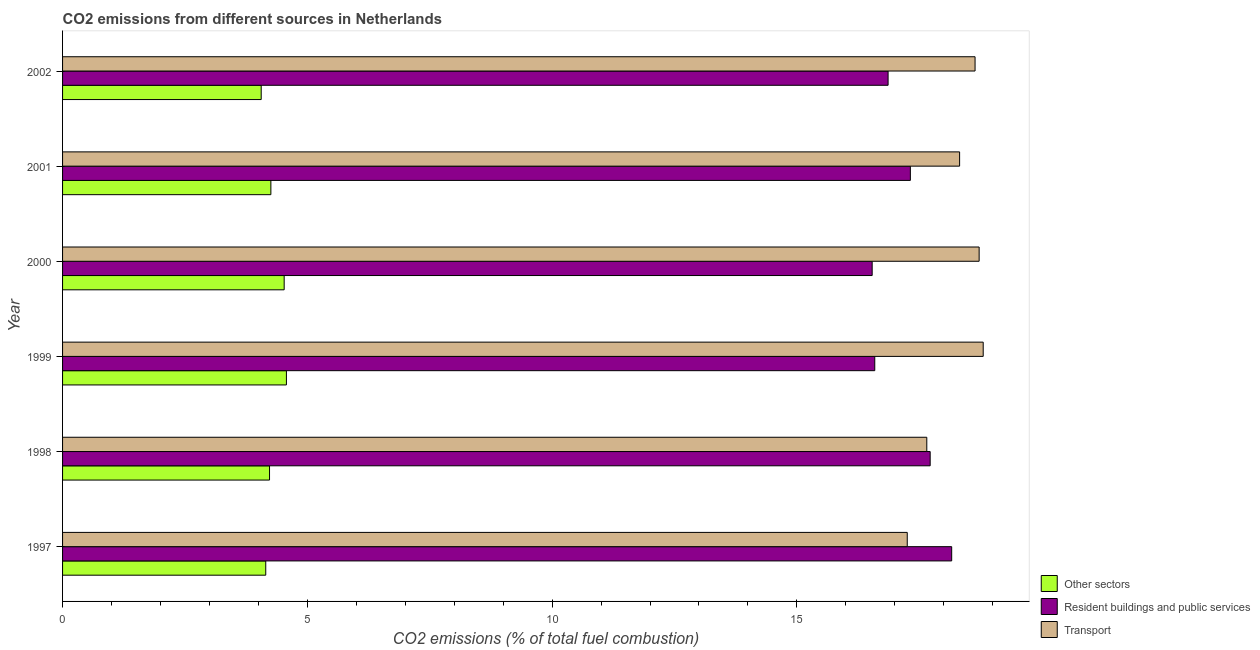Are the number of bars on each tick of the Y-axis equal?
Make the answer very short. Yes. How many bars are there on the 1st tick from the top?
Offer a terse response. 3. How many bars are there on the 4th tick from the bottom?
Your answer should be compact. 3. What is the percentage of co2 emissions from resident buildings and public services in 2000?
Your answer should be very brief. 16.54. Across all years, what is the maximum percentage of co2 emissions from other sectors?
Keep it short and to the point. 4.57. Across all years, what is the minimum percentage of co2 emissions from transport?
Your answer should be compact. 17.25. In which year was the percentage of co2 emissions from other sectors minimum?
Keep it short and to the point. 2002. What is the total percentage of co2 emissions from other sectors in the graph?
Ensure brevity in your answer.  25.79. What is the difference between the percentage of co2 emissions from transport in 1997 and that in 2002?
Your answer should be compact. -1.39. What is the difference between the percentage of co2 emissions from other sectors in 2001 and the percentage of co2 emissions from resident buildings and public services in 2002?
Give a very brief answer. -12.61. What is the average percentage of co2 emissions from transport per year?
Your answer should be compact. 18.23. In the year 1998, what is the difference between the percentage of co2 emissions from transport and percentage of co2 emissions from resident buildings and public services?
Your answer should be compact. -0.07. In how many years, is the percentage of co2 emissions from resident buildings and public services greater than 4 %?
Provide a succinct answer. 6. Is the percentage of co2 emissions from other sectors in 1998 less than that in 2001?
Make the answer very short. Yes. What is the difference between the highest and the second highest percentage of co2 emissions from other sectors?
Give a very brief answer. 0.05. What is the difference between the highest and the lowest percentage of co2 emissions from resident buildings and public services?
Your answer should be very brief. 1.62. In how many years, is the percentage of co2 emissions from transport greater than the average percentage of co2 emissions from transport taken over all years?
Provide a succinct answer. 4. Is the sum of the percentage of co2 emissions from resident buildings and public services in 1997 and 1998 greater than the maximum percentage of co2 emissions from transport across all years?
Keep it short and to the point. Yes. What does the 3rd bar from the top in 2001 represents?
Give a very brief answer. Other sectors. What does the 3rd bar from the bottom in 2000 represents?
Offer a very short reply. Transport. Is it the case that in every year, the sum of the percentage of co2 emissions from other sectors and percentage of co2 emissions from resident buildings and public services is greater than the percentage of co2 emissions from transport?
Give a very brief answer. Yes. Are all the bars in the graph horizontal?
Make the answer very short. Yes. Are the values on the major ticks of X-axis written in scientific E-notation?
Provide a succinct answer. No. Does the graph contain any zero values?
Ensure brevity in your answer.  No. Where does the legend appear in the graph?
Provide a short and direct response. Bottom right. How many legend labels are there?
Offer a very short reply. 3. What is the title of the graph?
Make the answer very short. CO2 emissions from different sources in Netherlands. What is the label or title of the X-axis?
Keep it short and to the point. CO2 emissions (% of total fuel combustion). What is the CO2 emissions (% of total fuel combustion) of Other sectors in 1997?
Offer a terse response. 4.15. What is the CO2 emissions (% of total fuel combustion) of Resident buildings and public services in 1997?
Keep it short and to the point. 18.16. What is the CO2 emissions (% of total fuel combustion) of Transport in 1997?
Provide a succinct answer. 17.25. What is the CO2 emissions (% of total fuel combustion) of Other sectors in 1998?
Offer a terse response. 4.23. What is the CO2 emissions (% of total fuel combustion) in Resident buildings and public services in 1998?
Your response must be concise. 17.72. What is the CO2 emissions (% of total fuel combustion) of Transport in 1998?
Keep it short and to the point. 17.65. What is the CO2 emissions (% of total fuel combustion) in Other sectors in 1999?
Provide a succinct answer. 4.57. What is the CO2 emissions (% of total fuel combustion) in Resident buildings and public services in 1999?
Provide a short and direct response. 16.59. What is the CO2 emissions (% of total fuel combustion) in Transport in 1999?
Make the answer very short. 18.81. What is the CO2 emissions (% of total fuel combustion) of Other sectors in 2000?
Make the answer very short. 4.53. What is the CO2 emissions (% of total fuel combustion) of Resident buildings and public services in 2000?
Your response must be concise. 16.54. What is the CO2 emissions (% of total fuel combustion) of Transport in 2000?
Provide a short and direct response. 18.72. What is the CO2 emissions (% of total fuel combustion) in Other sectors in 2001?
Your response must be concise. 4.25. What is the CO2 emissions (% of total fuel combustion) of Resident buildings and public services in 2001?
Your answer should be very brief. 17.32. What is the CO2 emissions (% of total fuel combustion) in Transport in 2001?
Ensure brevity in your answer.  18.32. What is the CO2 emissions (% of total fuel combustion) in Other sectors in 2002?
Offer a very short reply. 4.06. What is the CO2 emissions (% of total fuel combustion) in Resident buildings and public services in 2002?
Your response must be concise. 16.86. What is the CO2 emissions (% of total fuel combustion) of Transport in 2002?
Offer a terse response. 18.64. Across all years, what is the maximum CO2 emissions (% of total fuel combustion) in Other sectors?
Provide a succinct answer. 4.57. Across all years, what is the maximum CO2 emissions (% of total fuel combustion) of Resident buildings and public services?
Give a very brief answer. 18.16. Across all years, what is the maximum CO2 emissions (% of total fuel combustion) of Transport?
Keep it short and to the point. 18.81. Across all years, what is the minimum CO2 emissions (% of total fuel combustion) of Other sectors?
Your answer should be very brief. 4.06. Across all years, what is the minimum CO2 emissions (% of total fuel combustion) of Resident buildings and public services?
Give a very brief answer. 16.54. Across all years, what is the minimum CO2 emissions (% of total fuel combustion) in Transport?
Give a very brief answer. 17.25. What is the total CO2 emissions (% of total fuel combustion) in Other sectors in the graph?
Make the answer very short. 25.79. What is the total CO2 emissions (% of total fuel combustion) of Resident buildings and public services in the graph?
Your answer should be very brief. 103.19. What is the total CO2 emissions (% of total fuel combustion) of Transport in the graph?
Give a very brief answer. 109.4. What is the difference between the CO2 emissions (% of total fuel combustion) in Other sectors in 1997 and that in 1998?
Give a very brief answer. -0.08. What is the difference between the CO2 emissions (% of total fuel combustion) of Resident buildings and public services in 1997 and that in 1998?
Keep it short and to the point. 0.44. What is the difference between the CO2 emissions (% of total fuel combustion) in Transport in 1997 and that in 1998?
Offer a very short reply. -0.4. What is the difference between the CO2 emissions (% of total fuel combustion) of Other sectors in 1997 and that in 1999?
Ensure brevity in your answer.  -0.42. What is the difference between the CO2 emissions (% of total fuel combustion) of Resident buildings and public services in 1997 and that in 1999?
Your response must be concise. 1.57. What is the difference between the CO2 emissions (% of total fuel combustion) of Transport in 1997 and that in 1999?
Keep it short and to the point. -1.55. What is the difference between the CO2 emissions (% of total fuel combustion) of Other sectors in 1997 and that in 2000?
Give a very brief answer. -0.38. What is the difference between the CO2 emissions (% of total fuel combustion) in Resident buildings and public services in 1997 and that in 2000?
Keep it short and to the point. 1.62. What is the difference between the CO2 emissions (% of total fuel combustion) of Transport in 1997 and that in 2000?
Provide a succinct answer. -1.47. What is the difference between the CO2 emissions (% of total fuel combustion) in Other sectors in 1997 and that in 2001?
Give a very brief answer. -0.1. What is the difference between the CO2 emissions (% of total fuel combustion) in Resident buildings and public services in 1997 and that in 2001?
Your response must be concise. 0.84. What is the difference between the CO2 emissions (% of total fuel combustion) of Transport in 1997 and that in 2001?
Give a very brief answer. -1.07. What is the difference between the CO2 emissions (% of total fuel combustion) in Other sectors in 1997 and that in 2002?
Ensure brevity in your answer.  0.09. What is the difference between the CO2 emissions (% of total fuel combustion) in Resident buildings and public services in 1997 and that in 2002?
Provide a short and direct response. 1.3. What is the difference between the CO2 emissions (% of total fuel combustion) in Transport in 1997 and that in 2002?
Offer a very short reply. -1.39. What is the difference between the CO2 emissions (% of total fuel combustion) of Other sectors in 1998 and that in 1999?
Keep it short and to the point. -0.34. What is the difference between the CO2 emissions (% of total fuel combustion) in Resident buildings and public services in 1998 and that in 1999?
Ensure brevity in your answer.  1.13. What is the difference between the CO2 emissions (% of total fuel combustion) in Transport in 1998 and that in 1999?
Provide a succinct answer. -1.15. What is the difference between the CO2 emissions (% of total fuel combustion) of Other sectors in 1998 and that in 2000?
Provide a succinct answer. -0.3. What is the difference between the CO2 emissions (% of total fuel combustion) of Resident buildings and public services in 1998 and that in 2000?
Give a very brief answer. 1.18. What is the difference between the CO2 emissions (% of total fuel combustion) of Transport in 1998 and that in 2000?
Give a very brief answer. -1.07. What is the difference between the CO2 emissions (% of total fuel combustion) of Other sectors in 1998 and that in 2001?
Provide a short and direct response. -0.03. What is the difference between the CO2 emissions (% of total fuel combustion) of Resident buildings and public services in 1998 and that in 2001?
Provide a short and direct response. 0.4. What is the difference between the CO2 emissions (% of total fuel combustion) of Transport in 1998 and that in 2001?
Make the answer very short. -0.67. What is the difference between the CO2 emissions (% of total fuel combustion) in Other sectors in 1998 and that in 2002?
Your response must be concise. 0.17. What is the difference between the CO2 emissions (% of total fuel combustion) in Resident buildings and public services in 1998 and that in 2002?
Your answer should be compact. 0.86. What is the difference between the CO2 emissions (% of total fuel combustion) in Transport in 1998 and that in 2002?
Make the answer very short. -0.99. What is the difference between the CO2 emissions (% of total fuel combustion) in Other sectors in 1999 and that in 2000?
Ensure brevity in your answer.  0.05. What is the difference between the CO2 emissions (% of total fuel combustion) in Resident buildings and public services in 1999 and that in 2000?
Provide a succinct answer. 0.05. What is the difference between the CO2 emissions (% of total fuel combustion) in Transport in 1999 and that in 2000?
Make the answer very short. 0.08. What is the difference between the CO2 emissions (% of total fuel combustion) in Other sectors in 1999 and that in 2001?
Offer a very short reply. 0.32. What is the difference between the CO2 emissions (% of total fuel combustion) of Resident buildings and public services in 1999 and that in 2001?
Your answer should be very brief. -0.73. What is the difference between the CO2 emissions (% of total fuel combustion) of Transport in 1999 and that in 2001?
Ensure brevity in your answer.  0.48. What is the difference between the CO2 emissions (% of total fuel combustion) of Other sectors in 1999 and that in 2002?
Your answer should be very brief. 0.52. What is the difference between the CO2 emissions (% of total fuel combustion) in Resident buildings and public services in 1999 and that in 2002?
Your answer should be compact. -0.27. What is the difference between the CO2 emissions (% of total fuel combustion) in Transport in 1999 and that in 2002?
Provide a succinct answer. 0.17. What is the difference between the CO2 emissions (% of total fuel combustion) in Other sectors in 2000 and that in 2001?
Offer a very short reply. 0.27. What is the difference between the CO2 emissions (% of total fuel combustion) in Resident buildings and public services in 2000 and that in 2001?
Keep it short and to the point. -0.78. What is the difference between the CO2 emissions (% of total fuel combustion) of Transport in 2000 and that in 2001?
Keep it short and to the point. 0.4. What is the difference between the CO2 emissions (% of total fuel combustion) of Other sectors in 2000 and that in 2002?
Keep it short and to the point. 0.47. What is the difference between the CO2 emissions (% of total fuel combustion) of Resident buildings and public services in 2000 and that in 2002?
Your answer should be very brief. -0.33. What is the difference between the CO2 emissions (% of total fuel combustion) in Transport in 2000 and that in 2002?
Ensure brevity in your answer.  0.08. What is the difference between the CO2 emissions (% of total fuel combustion) in Other sectors in 2001 and that in 2002?
Make the answer very short. 0.2. What is the difference between the CO2 emissions (% of total fuel combustion) in Resident buildings and public services in 2001 and that in 2002?
Offer a terse response. 0.45. What is the difference between the CO2 emissions (% of total fuel combustion) in Transport in 2001 and that in 2002?
Offer a terse response. -0.32. What is the difference between the CO2 emissions (% of total fuel combustion) of Other sectors in 1997 and the CO2 emissions (% of total fuel combustion) of Resident buildings and public services in 1998?
Give a very brief answer. -13.57. What is the difference between the CO2 emissions (% of total fuel combustion) of Other sectors in 1997 and the CO2 emissions (% of total fuel combustion) of Transport in 1998?
Offer a terse response. -13.5. What is the difference between the CO2 emissions (% of total fuel combustion) of Resident buildings and public services in 1997 and the CO2 emissions (% of total fuel combustion) of Transport in 1998?
Provide a succinct answer. 0.51. What is the difference between the CO2 emissions (% of total fuel combustion) in Other sectors in 1997 and the CO2 emissions (% of total fuel combustion) in Resident buildings and public services in 1999?
Your response must be concise. -12.44. What is the difference between the CO2 emissions (% of total fuel combustion) in Other sectors in 1997 and the CO2 emissions (% of total fuel combustion) in Transport in 1999?
Provide a succinct answer. -14.66. What is the difference between the CO2 emissions (% of total fuel combustion) in Resident buildings and public services in 1997 and the CO2 emissions (% of total fuel combustion) in Transport in 1999?
Keep it short and to the point. -0.64. What is the difference between the CO2 emissions (% of total fuel combustion) of Other sectors in 1997 and the CO2 emissions (% of total fuel combustion) of Resident buildings and public services in 2000?
Your answer should be compact. -12.39. What is the difference between the CO2 emissions (% of total fuel combustion) of Other sectors in 1997 and the CO2 emissions (% of total fuel combustion) of Transport in 2000?
Make the answer very short. -14.57. What is the difference between the CO2 emissions (% of total fuel combustion) of Resident buildings and public services in 1997 and the CO2 emissions (% of total fuel combustion) of Transport in 2000?
Offer a terse response. -0.56. What is the difference between the CO2 emissions (% of total fuel combustion) in Other sectors in 1997 and the CO2 emissions (% of total fuel combustion) in Resident buildings and public services in 2001?
Provide a succinct answer. -13.17. What is the difference between the CO2 emissions (% of total fuel combustion) of Other sectors in 1997 and the CO2 emissions (% of total fuel combustion) of Transport in 2001?
Offer a terse response. -14.17. What is the difference between the CO2 emissions (% of total fuel combustion) of Resident buildings and public services in 1997 and the CO2 emissions (% of total fuel combustion) of Transport in 2001?
Your answer should be compact. -0.16. What is the difference between the CO2 emissions (% of total fuel combustion) of Other sectors in 1997 and the CO2 emissions (% of total fuel combustion) of Resident buildings and public services in 2002?
Provide a short and direct response. -12.71. What is the difference between the CO2 emissions (% of total fuel combustion) of Other sectors in 1997 and the CO2 emissions (% of total fuel combustion) of Transport in 2002?
Give a very brief answer. -14.49. What is the difference between the CO2 emissions (% of total fuel combustion) in Resident buildings and public services in 1997 and the CO2 emissions (% of total fuel combustion) in Transport in 2002?
Provide a short and direct response. -0.48. What is the difference between the CO2 emissions (% of total fuel combustion) of Other sectors in 1998 and the CO2 emissions (% of total fuel combustion) of Resident buildings and public services in 1999?
Provide a succinct answer. -12.36. What is the difference between the CO2 emissions (% of total fuel combustion) of Other sectors in 1998 and the CO2 emissions (% of total fuel combustion) of Transport in 1999?
Your answer should be compact. -14.58. What is the difference between the CO2 emissions (% of total fuel combustion) of Resident buildings and public services in 1998 and the CO2 emissions (% of total fuel combustion) of Transport in 1999?
Your response must be concise. -1.08. What is the difference between the CO2 emissions (% of total fuel combustion) in Other sectors in 1998 and the CO2 emissions (% of total fuel combustion) in Resident buildings and public services in 2000?
Your answer should be compact. -12.31. What is the difference between the CO2 emissions (% of total fuel combustion) of Other sectors in 1998 and the CO2 emissions (% of total fuel combustion) of Transport in 2000?
Give a very brief answer. -14.5. What is the difference between the CO2 emissions (% of total fuel combustion) of Resident buildings and public services in 1998 and the CO2 emissions (% of total fuel combustion) of Transport in 2000?
Give a very brief answer. -1. What is the difference between the CO2 emissions (% of total fuel combustion) of Other sectors in 1998 and the CO2 emissions (% of total fuel combustion) of Resident buildings and public services in 2001?
Keep it short and to the point. -13.09. What is the difference between the CO2 emissions (% of total fuel combustion) in Other sectors in 1998 and the CO2 emissions (% of total fuel combustion) in Transport in 2001?
Your answer should be compact. -14.1. What is the difference between the CO2 emissions (% of total fuel combustion) in Resident buildings and public services in 1998 and the CO2 emissions (% of total fuel combustion) in Transport in 2001?
Give a very brief answer. -0.6. What is the difference between the CO2 emissions (% of total fuel combustion) of Other sectors in 1998 and the CO2 emissions (% of total fuel combustion) of Resident buildings and public services in 2002?
Make the answer very short. -12.64. What is the difference between the CO2 emissions (% of total fuel combustion) in Other sectors in 1998 and the CO2 emissions (% of total fuel combustion) in Transport in 2002?
Your answer should be compact. -14.41. What is the difference between the CO2 emissions (% of total fuel combustion) of Resident buildings and public services in 1998 and the CO2 emissions (% of total fuel combustion) of Transport in 2002?
Offer a very short reply. -0.92. What is the difference between the CO2 emissions (% of total fuel combustion) of Other sectors in 1999 and the CO2 emissions (% of total fuel combustion) of Resident buildings and public services in 2000?
Your answer should be very brief. -11.97. What is the difference between the CO2 emissions (% of total fuel combustion) in Other sectors in 1999 and the CO2 emissions (% of total fuel combustion) in Transport in 2000?
Keep it short and to the point. -14.15. What is the difference between the CO2 emissions (% of total fuel combustion) of Resident buildings and public services in 1999 and the CO2 emissions (% of total fuel combustion) of Transport in 2000?
Make the answer very short. -2.13. What is the difference between the CO2 emissions (% of total fuel combustion) in Other sectors in 1999 and the CO2 emissions (% of total fuel combustion) in Resident buildings and public services in 2001?
Provide a succinct answer. -12.75. What is the difference between the CO2 emissions (% of total fuel combustion) in Other sectors in 1999 and the CO2 emissions (% of total fuel combustion) in Transport in 2001?
Your answer should be compact. -13.75. What is the difference between the CO2 emissions (% of total fuel combustion) in Resident buildings and public services in 1999 and the CO2 emissions (% of total fuel combustion) in Transport in 2001?
Your response must be concise. -1.73. What is the difference between the CO2 emissions (% of total fuel combustion) in Other sectors in 1999 and the CO2 emissions (% of total fuel combustion) in Resident buildings and public services in 2002?
Offer a terse response. -12.29. What is the difference between the CO2 emissions (% of total fuel combustion) in Other sectors in 1999 and the CO2 emissions (% of total fuel combustion) in Transport in 2002?
Keep it short and to the point. -14.07. What is the difference between the CO2 emissions (% of total fuel combustion) in Resident buildings and public services in 1999 and the CO2 emissions (% of total fuel combustion) in Transport in 2002?
Your answer should be compact. -2.05. What is the difference between the CO2 emissions (% of total fuel combustion) in Other sectors in 2000 and the CO2 emissions (% of total fuel combustion) in Resident buildings and public services in 2001?
Offer a terse response. -12.79. What is the difference between the CO2 emissions (% of total fuel combustion) in Other sectors in 2000 and the CO2 emissions (% of total fuel combustion) in Transport in 2001?
Provide a succinct answer. -13.8. What is the difference between the CO2 emissions (% of total fuel combustion) of Resident buildings and public services in 2000 and the CO2 emissions (% of total fuel combustion) of Transport in 2001?
Offer a very short reply. -1.79. What is the difference between the CO2 emissions (% of total fuel combustion) of Other sectors in 2000 and the CO2 emissions (% of total fuel combustion) of Resident buildings and public services in 2002?
Your response must be concise. -12.34. What is the difference between the CO2 emissions (% of total fuel combustion) in Other sectors in 2000 and the CO2 emissions (% of total fuel combustion) in Transport in 2002?
Give a very brief answer. -14.11. What is the difference between the CO2 emissions (% of total fuel combustion) of Resident buildings and public services in 2000 and the CO2 emissions (% of total fuel combustion) of Transport in 2002?
Your response must be concise. -2.1. What is the difference between the CO2 emissions (% of total fuel combustion) in Other sectors in 2001 and the CO2 emissions (% of total fuel combustion) in Resident buildings and public services in 2002?
Offer a very short reply. -12.61. What is the difference between the CO2 emissions (% of total fuel combustion) in Other sectors in 2001 and the CO2 emissions (% of total fuel combustion) in Transport in 2002?
Ensure brevity in your answer.  -14.38. What is the difference between the CO2 emissions (% of total fuel combustion) in Resident buildings and public services in 2001 and the CO2 emissions (% of total fuel combustion) in Transport in 2002?
Make the answer very short. -1.32. What is the average CO2 emissions (% of total fuel combustion) in Other sectors per year?
Offer a very short reply. 4.3. What is the average CO2 emissions (% of total fuel combustion) of Resident buildings and public services per year?
Keep it short and to the point. 17.2. What is the average CO2 emissions (% of total fuel combustion) of Transport per year?
Your answer should be very brief. 18.23. In the year 1997, what is the difference between the CO2 emissions (% of total fuel combustion) in Other sectors and CO2 emissions (% of total fuel combustion) in Resident buildings and public services?
Ensure brevity in your answer.  -14.01. In the year 1997, what is the difference between the CO2 emissions (% of total fuel combustion) in Other sectors and CO2 emissions (% of total fuel combustion) in Transport?
Ensure brevity in your answer.  -13.1. In the year 1997, what is the difference between the CO2 emissions (% of total fuel combustion) of Resident buildings and public services and CO2 emissions (% of total fuel combustion) of Transport?
Offer a very short reply. 0.91. In the year 1998, what is the difference between the CO2 emissions (% of total fuel combustion) of Other sectors and CO2 emissions (% of total fuel combustion) of Resident buildings and public services?
Make the answer very short. -13.49. In the year 1998, what is the difference between the CO2 emissions (% of total fuel combustion) in Other sectors and CO2 emissions (% of total fuel combustion) in Transport?
Make the answer very short. -13.43. In the year 1998, what is the difference between the CO2 emissions (% of total fuel combustion) in Resident buildings and public services and CO2 emissions (% of total fuel combustion) in Transport?
Your answer should be compact. 0.07. In the year 1999, what is the difference between the CO2 emissions (% of total fuel combustion) in Other sectors and CO2 emissions (% of total fuel combustion) in Resident buildings and public services?
Keep it short and to the point. -12.02. In the year 1999, what is the difference between the CO2 emissions (% of total fuel combustion) of Other sectors and CO2 emissions (% of total fuel combustion) of Transport?
Ensure brevity in your answer.  -14.23. In the year 1999, what is the difference between the CO2 emissions (% of total fuel combustion) of Resident buildings and public services and CO2 emissions (% of total fuel combustion) of Transport?
Your answer should be very brief. -2.22. In the year 2000, what is the difference between the CO2 emissions (% of total fuel combustion) in Other sectors and CO2 emissions (% of total fuel combustion) in Resident buildings and public services?
Ensure brevity in your answer.  -12.01. In the year 2000, what is the difference between the CO2 emissions (% of total fuel combustion) of Other sectors and CO2 emissions (% of total fuel combustion) of Transport?
Offer a very short reply. -14.2. In the year 2000, what is the difference between the CO2 emissions (% of total fuel combustion) in Resident buildings and public services and CO2 emissions (% of total fuel combustion) in Transport?
Your response must be concise. -2.18. In the year 2001, what is the difference between the CO2 emissions (% of total fuel combustion) in Other sectors and CO2 emissions (% of total fuel combustion) in Resident buildings and public services?
Offer a terse response. -13.06. In the year 2001, what is the difference between the CO2 emissions (% of total fuel combustion) in Other sectors and CO2 emissions (% of total fuel combustion) in Transport?
Your response must be concise. -14.07. In the year 2001, what is the difference between the CO2 emissions (% of total fuel combustion) of Resident buildings and public services and CO2 emissions (% of total fuel combustion) of Transport?
Offer a very short reply. -1.01. In the year 2002, what is the difference between the CO2 emissions (% of total fuel combustion) of Other sectors and CO2 emissions (% of total fuel combustion) of Resident buildings and public services?
Ensure brevity in your answer.  -12.81. In the year 2002, what is the difference between the CO2 emissions (% of total fuel combustion) of Other sectors and CO2 emissions (% of total fuel combustion) of Transport?
Provide a short and direct response. -14.58. In the year 2002, what is the difference between the CO2 emissions (% of total fuel combustion) of Resident buildings and public services and CO2 emissions (% of total fuel combustion) of Transport?
Your answer should be compact. -1.78. What is the ratio of the CO2 emissions (% of total fuel combustion) in Other sectors in 1997 to that in 1998?
Offer a very short reply. 0.98. What is the ratio of the CO2 emissions (% of total fuel combustion) in Resident buildings and public services in 1997 to that in 1998?
Your answer should be very brief. 1.02. What is the ratio of the CO2 emissions (% of total fuel combustion) in Transport in 1997 to that in 1998?
Provide a short and direct response. 0.98. What is the ratio of the CO2 emissions (% of total fuel combustion) in Other sectors in 1997 to that in 1999?
Provide a short and direct response. 0.91. What is the ratio of the CO2 emissions (% of total fuel combustion) of Resident buildings and public services in 1997 to that in 1999?
Your answer should be compact. 1.09. What is the ratio of the CO2 emissions (% of total fuel combustion) in Transport in 1997 to that in 1999?
Provide a short and direct response. 0.92. What is the ratio of the CO2 emissions (% of total fuel combustion) of Other sectors in 1997 to that in 2000?
Provide a short and direct response. 0.92. What is the ratio of the CO2 emissions (% of total fuel combustion) in Resident buildings and public services in 1997 to that in 2000?
Your answer should be very brief. 1.1. What is the ratio of the CO2 emissions (% of total fuel combustion) of Transport in 1997 to that in 2000?
Your answer should be very brief. 0.92. What is the ratio of the CO2 emissions (% of total fuel combustion) of Other sectors in 1997 to that in 2001?
Your answer should be compact. 0.98. What is the ratio of the CO2 emissions (% of total fuel combustion) of Resident buildings and public services in 1997 to that in 2001?
Your answer should be very brief. 1.05. What is the ratio of the CO2 emissions (% of total fuel combustion) in Transport in 1997 to that in 2001?
Provide a short and direct response. 0.94. What is the ratio of the CO2 emissions (% of total fuel combustion) in Other sectors in 1997 to that in 2002?
Keep it short and to the point. 1.02. What is the ratio of the CO2 emissions (% of total fuel combustion) in Resident buildings and public services in 1997 to that in 2002?
Ensure brevity in your answer.  1.08. What is the ratio of the CO2 emissions (% of total fuel combustion) in Transport in 1997 to that in 2002?
Give a very brief answer. 0.93. What is the ratio of the CO2 emissions (% of total fuel combustion) of Other sectors in 1998 to that in 1999?
Ensure brevity in your answer.  0.92. What is the ratio of the CO2 emissions (% of total fuel combustion) of Resident buildings and public services in 1998 to that in 1999?
Provide a succinct answer. 1.07. What is the ratio of the CO2 emissions (% of total fuel combustion) of Transport in 1998 to that in 1999?
Keep it short and to the point. 0.94. What is the ratio of the CO2 emissions (% of total fuel combustion) in Other sectors in 1998 to that in 2000?
Provide a succinct answer. 0.93. What is the ratio of the CO2 emissions (% of total fuel combustion) of Resident buildings and public services in 1998 to that in 2000?
Your answer should be compact. 1.07. What is the ratio of the CO2 emissions (% of total fuel combustion) of Transport in 1998 to that in 2000?
Your answer should be compact. 0.94. What is the ratio of the CO2 emissions (% of total fuel combustion) of Other sectors in 1998 to that in 2001?
Your response must be concise. 0.99. What is the ratio of the CO2 emissions (% of total fuel combustion) in Resident buildings and public services in 1998 to that in 2001?
Provide a short and direct response. 1.02. What is the ratio of the CO2 emissions (% of total fuel combustion) of Transport in 1998 to that in 2001?
Provide a succinct answer. 0.96. What is the ratio of the CO2 emissions (% of total fuel combustion) in Other sectors in 1998 to that in 2002?
Make the answer very short. 1.04. What is the ratio of the CO2 emissions (% of total fuel combustion) of Resident buildings and public services in 1998 to that in 2002?
Offer a very short reply. 1.05. What is the ratio of the CO2 emissions (% of total fuel combustion) in Transport in 1998 to that in 2002?
Keep it short and to the point. 0.95. What is the ratio of the CO2 emissions (% of total fuel combustion) of Other sectors in 1999 to that in 2001?
Offer a very short reply. 1.07. What is the ratio of the CO2 emissions (% of total fuel combustion) in Resident buildings and public services in 1999 to that in 2001?
Provide a short and direct response. 0.96. What is the ratio of the CO2 emissions (% of total fuel combustion) in Transport in 1999 to that in 2001?
Offer a very short reply. 1.03. What is the ratio of the CO2 emissions (% of total fuel combustion) of Other sectors in 1999 to that in 2002?
Ensure brevity in your answer.  1.13. What is the ratio of the CO2 emissions (% of total fuel combustion) of Resident buildings and public services in 1999 to that in 2002?
Ensure brevity in your answer.  0.98. What is the ratio of the CO2 emissions (% of total fuel combustion) in Transport in 1999 to that in 2002?
Keep it short and to the point. 1.01. What is the ratio of the CO2 emissions (% of total fuel combustion) in Other sectors in 2000 to that in 2001?
Offer a very short reply. 1.06. What is the ratio of the CO2 emissions (% of total fuel combustion) in Resident buildings and public services in 2000 to that in 2001?
Your response must be concise. 0.95. What is the ratio of the CO2 emissions (% of total fuel combustion) of Transport in 2000 to that in 2001?
Keep it short and to the point. 1.02. What is the ratio of the CO2 emissions (% of total fuel combustion) in Other sectors in 2000 to that in 2002?
Provide a short and direct response. 1.12. What is the ratio of the CO2 emissions (% of total fuel combustion) of Resident buildings and public services in 2000 to that in 2002?
Your answer should be very brief. 0.98. What is the ratio of the CO2 emissions (% of total fuel combustion) of Other sectors in 2001 to that in 2002?
Give a very brief answer. 1.05. What is the ratio of the CO2 emissions (% of total fuel combustion) in Transport in 2001 to that in 2002?
Your answer should be compact. 0.98. What is the difference between the highest and the second highest CO2 emissions (% of total fuel combustion) of Other sectors?
Offer a very short reply. 0.05. What is the difference between the highest and the second highest CO2 emissions (% of total fuel combustion) of Resident buildings and public services?
Offer a terse response. 0.44. What is the difference between the highest and the second highest CO2 emissions (% of total fuel combustion) of Transport?
Your answer should be compact. 0.08. What is the difference between the highest and the lowest CO2 emissions (% of total fuel combustion) of Other sectors?
Give a very brief answer. 0.52. What is the difference between the highest and the lowest CO2 emissions (% of total fuel combustion) in Resident buildings and public services?
Your answer should be compact. 1.62. What is the difference between the highest and the lowest CO2 emissions (% of total fuel combustion) of Transport?
Provide a succinct answer. 1.55. 